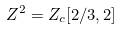Convert formula to latex. <formula><loc_0><loc_0><loc_500><loc_500>Z ^ { 2 } = Z _ { c } [ 2 / 3 , 2 ]</formula> 